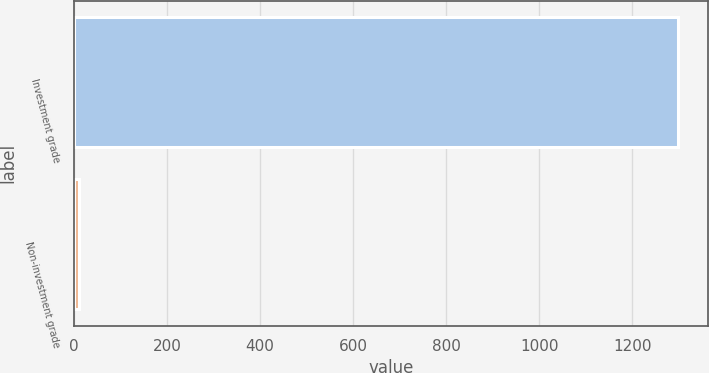<chart> <loc_0><loc_0><loc_500><loc_500><bar_chart><fcel>Investment grade<fcel>Non-investment grade<nl><fcel>1299<fcel>11<nl></chart> 